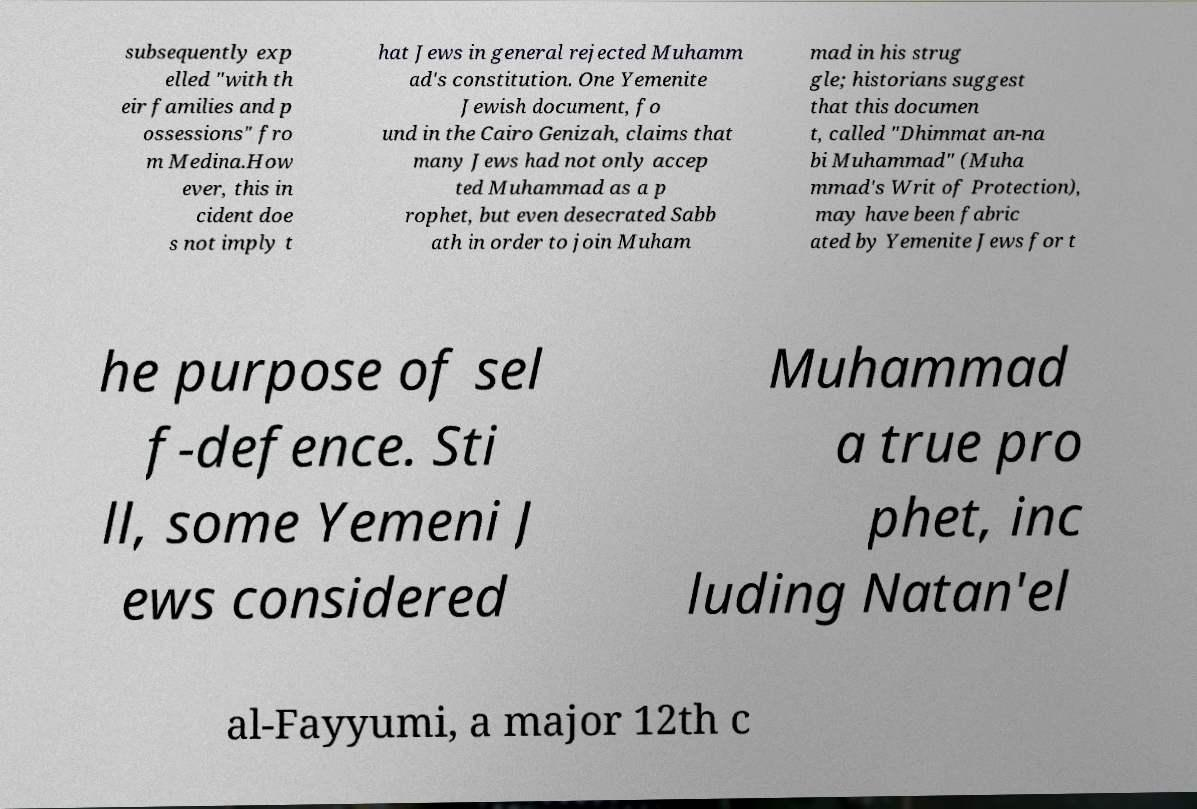Can you accurately transcribe the text from the provided image for me? subsequently exp elled "with th eir families and p ossessions" fro m Medina.How ever, this in cident doe s not imply t hat Jews in general rejected Muhamm ad's constitution. One Yemenite Jewish document, fo und in the Cairo Genizah, claims that many Jews had not only accep ted Muhammad as a p rophet, but even desecrated Sabb ath in order to join Muham mad in his strug gle; historians suggest that this documen t, called "Dhimmat an-na bi Muhammad" (Muha mmad's Writ of Protection), may have been fabric ated by Yemenite Jews for t he purpose of sel f-defence. Sti ll, some Yemeni J ews considered Muhammad a true pro phet, inc luding Natan'el al-Fayyumi, a major 12th c 